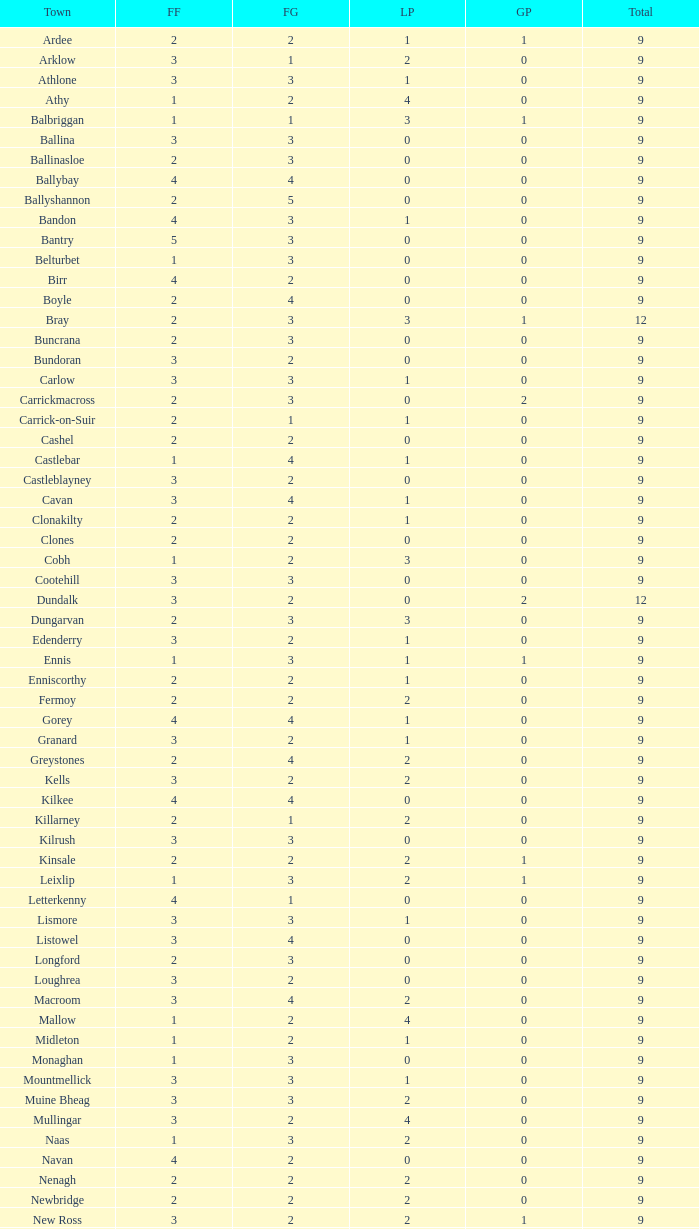How many are in the Labour Party of a Fianna Fail of 3 with a total higher than 9 and more than 2 in the Green Party? None. 